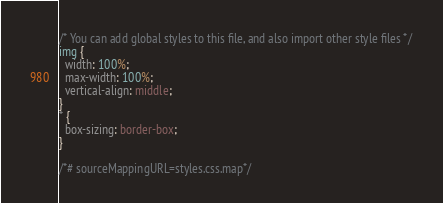Convert code to text. <code><loc_0><loc_0><loc_500><loc_500><_CSS_>/* You can add global styles to this file, and also import other style files */
img {
  width: 100%;
  max-width: 100%;
  vertical-align: middle;
}
* {
  box-sizing: border-box;
}

/*# sourceMappingURL=styles.css.map*/</code> 